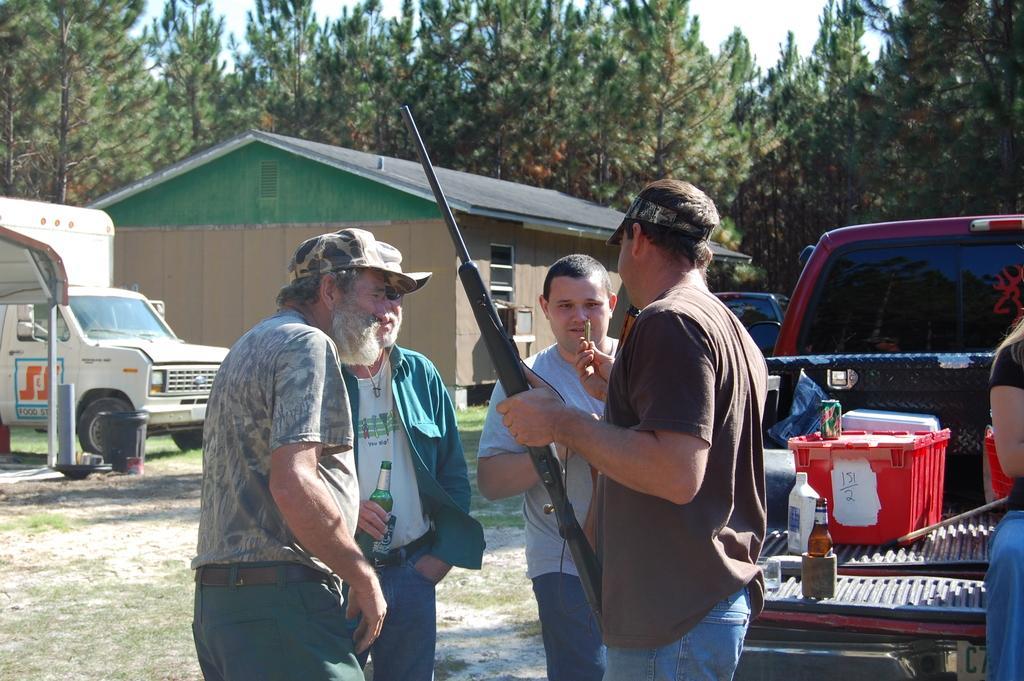How would you summarize this image in a sentence or two? In this picture I can see there is a man holding a gun and a bullet. There is a truck and there is a person sitting in it. In the backdrop there is a building and there are trees and the sky is clear. 